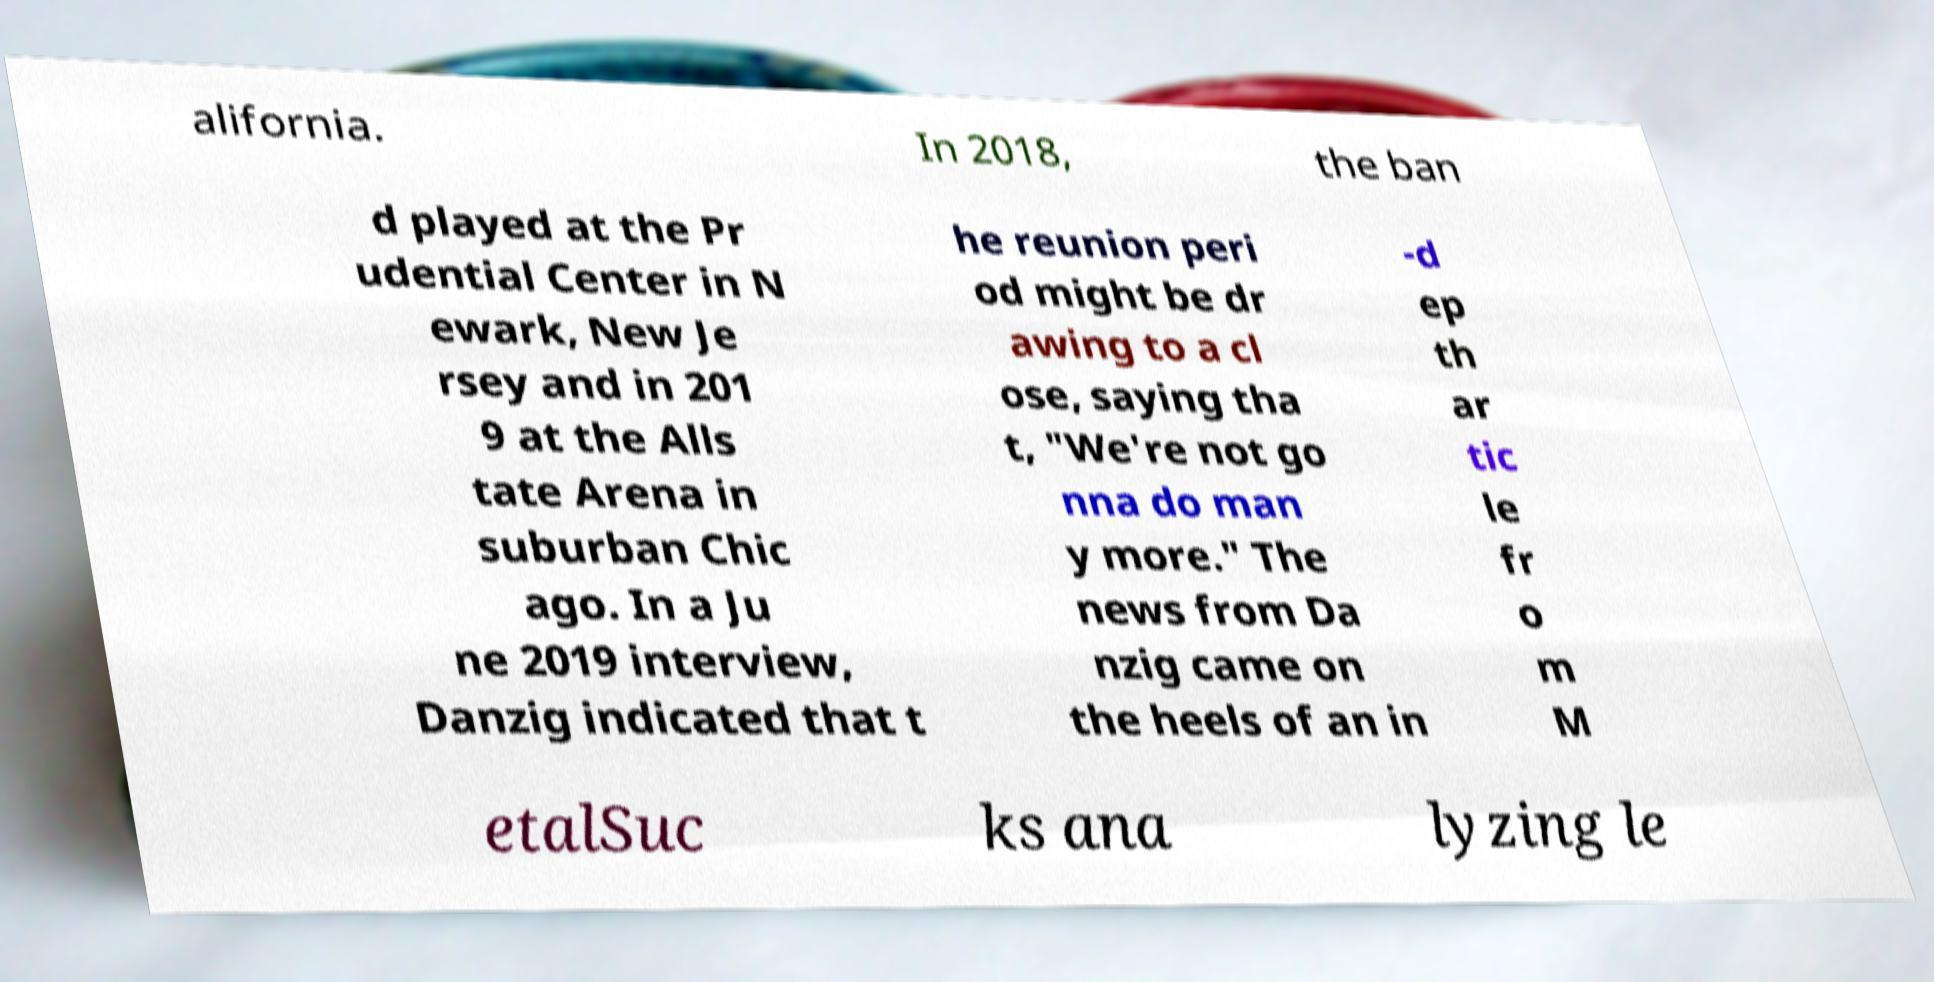I need the written content from this picture converted into text. Can you do that? alifornia. In 2018, the ban d played at the Pr udential Center in N ewark, New Je rsey and in 201 9 at the Alls tate Arena in suburban Chic ago. In a Ju ne 2019 interview, Danzig indicated that t he reunion peri od might be dr awing to a cl ose, saying tha t, "We're not go nna do man y more." The news from Da nzig came on the heels of an in -d ep th ar tic le fr o m M etalSuc ks ana lyzing le 